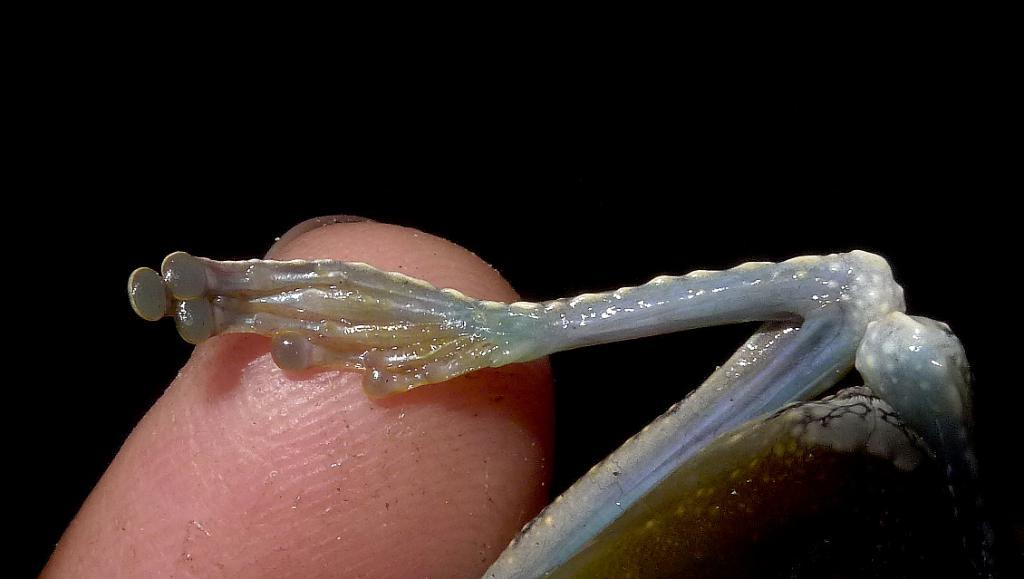What is the main subject of the image? There is a person's finger visible in the center of the image. Are there any other living creatures in the image besides the person's finger? Yes, there is an insect on the right side of the image. What type of cub can be seen playing with an arch in the image? There is no cub or arch present in the image; it only features a person's finger and an insect. 